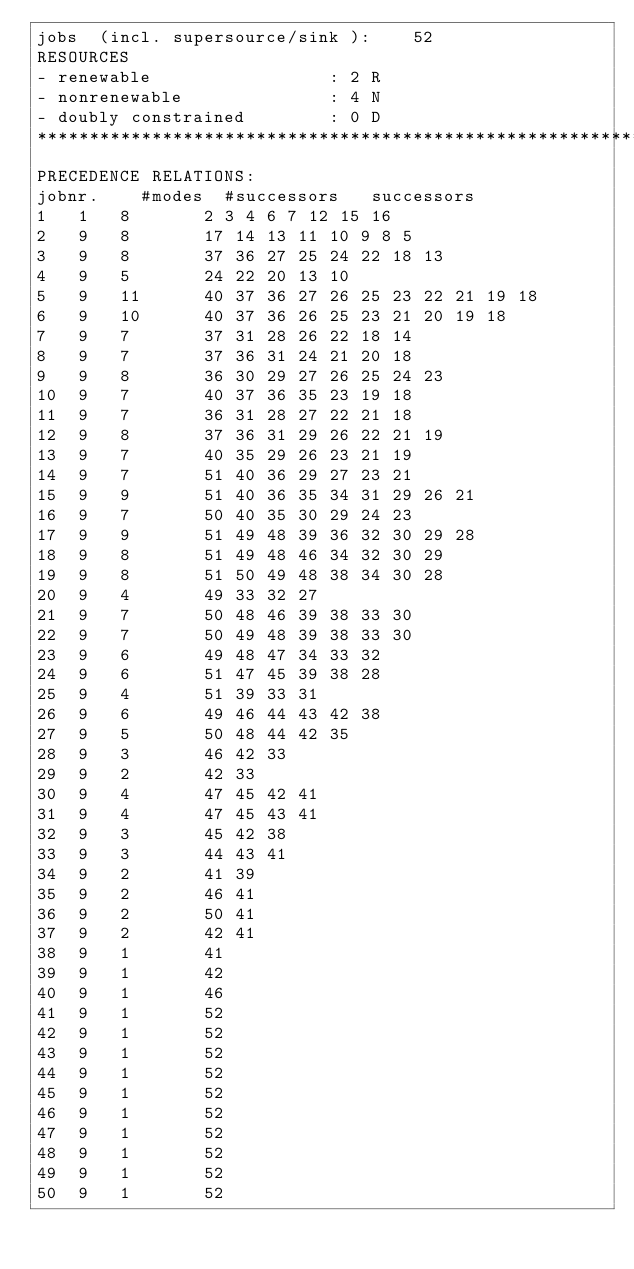Convert code to text. <code><loc_0><loc_0><loc_500><loc_500><_ObjectiveC_>jobs  (incl. supersource/sink ):	52
RESOURCES
- renewable                 : 2 R
- nonrenewable              : 4 N
- doubly constrained        : 0 D
************************************************************************
PRECEDENCE RELATIONS:
jobnr.    #modes  #successors   successors
1	1	8		2 3 4 6 7 12 15 16 
2	9	8		17 14 13 11 10 9 8 5 
3	9	8		37 36 27 25 24 22 18 13 
4	9	5		24 22 20 13 10 
5	9	11		40 37 36 27 26 25 23 22 21 19 18 
6	9	10		40 37 36 26 25 23 21 20 19 18 
7	9	7		37 31 28 26 22 18 14 
8	9	7		37 36 31 24 21 20 18 
9	9	8		36 30 29 27 26 25 24 23 
10	9	7		40 37 36 35 23 19 18 
11	9	7		36 31 28 27 22 21 18 
12	9	8		37 36 31 29 26 22 21 19 
13	9	7		40 35 29 26 23 21 19 
14	9	7		51 40 36 29 27 23 21 
15	9	9		51 40 36 35 34 31 29 26 21 
16	9	7		50 40 35 30 29 24 23 
17	9	9		51 49 48 39 36 32 30 29 28 
18	9	8		51 49 48 46 34 32 30 29 
19	9	8		51 50 49 48 38 34 30 28 
20	9	4		49 33 32 27 
21	9	7		50 48 46 39 38 33 30 
22	9	7		50 49 48 39 38 33 30 
23	9	6		49 48 47 34 33 32 
24	9	6		51 47 45 39 38 28 
25	9	4		51 39 33 31 
26	9	6		49 46 44 43 42 38 
27	9	5		50 48 44 42 35 
28	9	3		46 42 33 
29	9	2		42 33 
30	9	4		47 45 42 41 
31	9	4		47 45 43 41 
32	9	3		45 42 38 
33	9	3		44 43 41 
34	9	2		41 39 
35	9	2		46 41 
36	9	2		50 41 
37	9	2		42 41 
38	9	1		41 
39	9	1		42 
40	9	1		46 
41	9	1		52 
42	9	1		52 
43	9	1		52 
44	9	1		52 
45	9	1		52 
46	9	1		52 
47	9	1		52 
48	9	1		52 
49	9	1		52 
50	9	1		52 </code> 